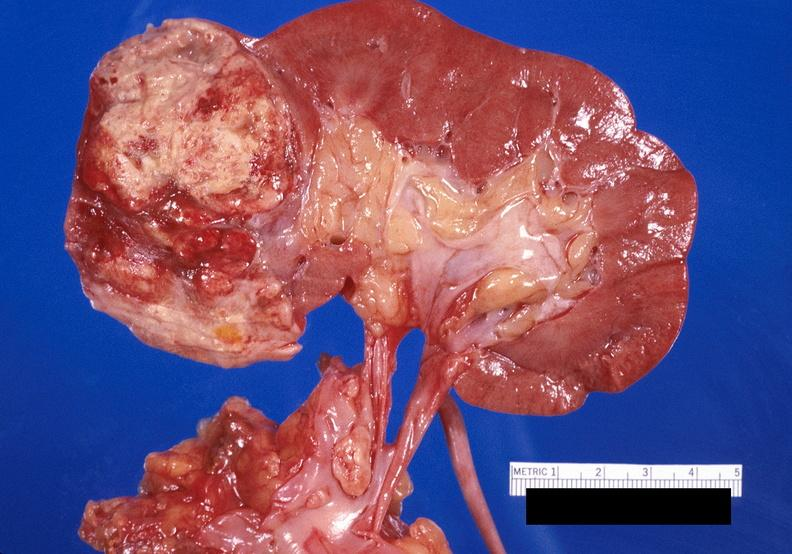what does this image show?
Answer the question using a single word or phrase. Renal cell carcinoma with extension into vena cava 